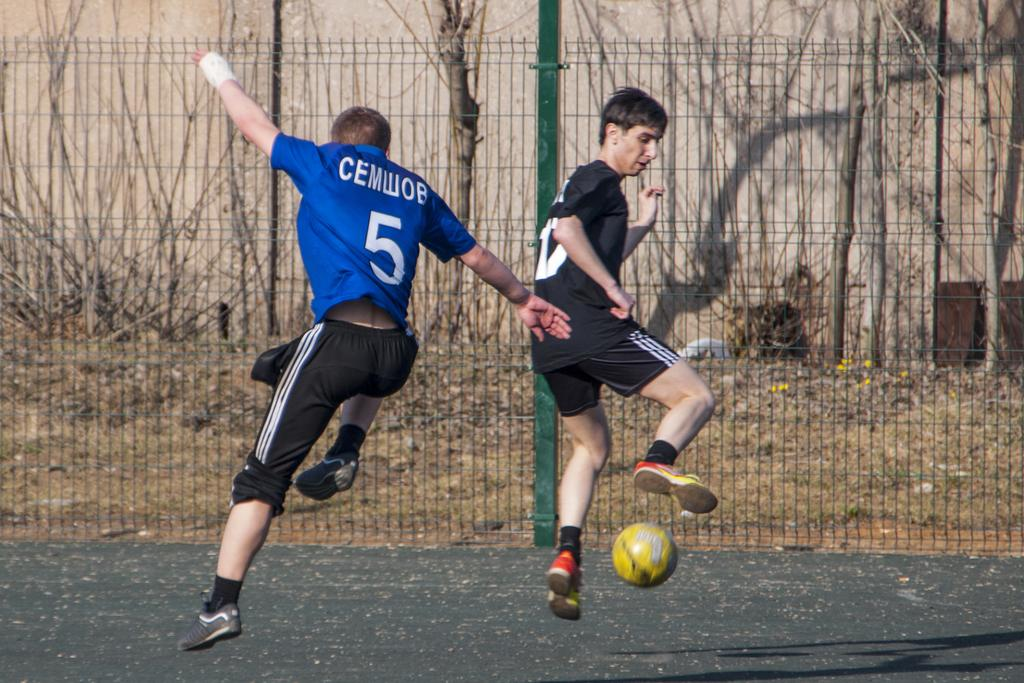<image>
Share a concise interpretation of the image provided. 2 athletes playing soccer in the street, one of the jerseys says: Cemwob #5. 